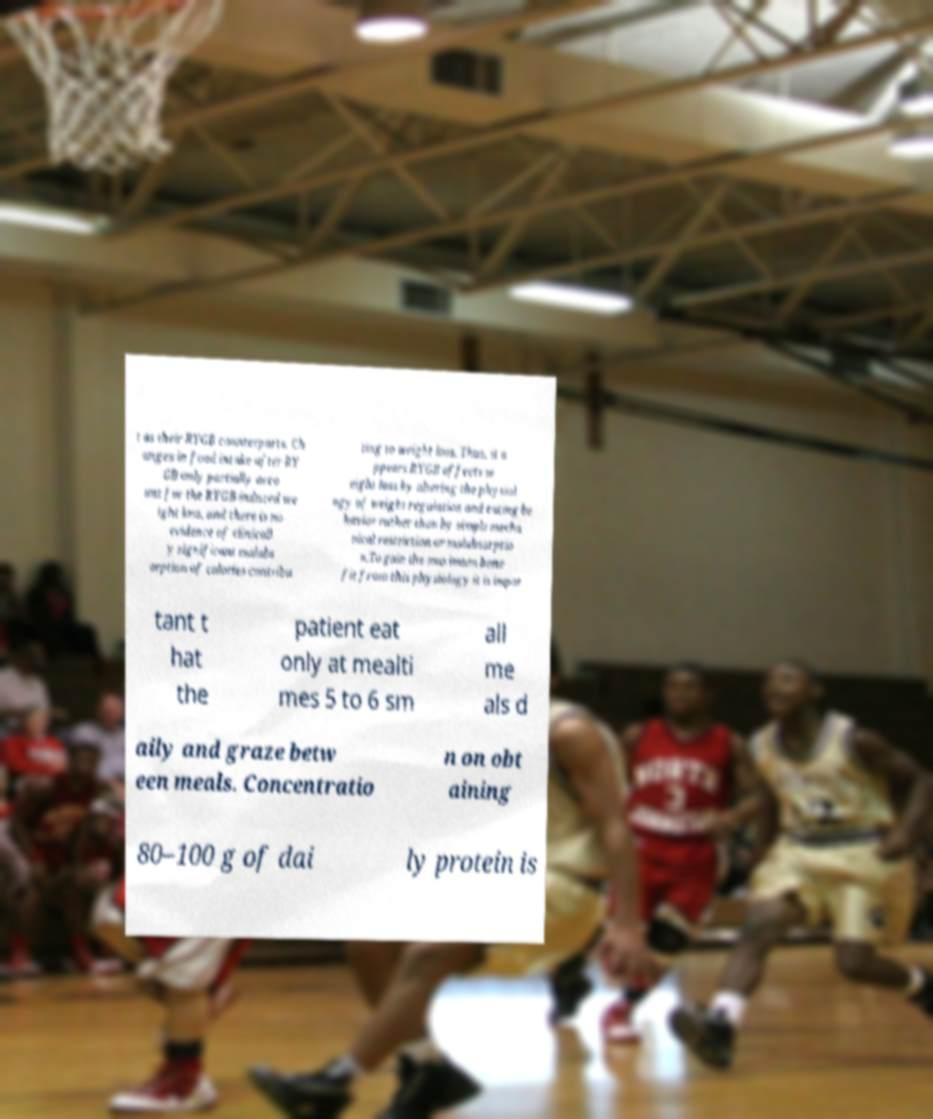I need the written content from this picture converted into text. Can you do that? t as their RYGB counterparts. Ch anges in food intake after RY GB only partially acco unt for the RYGB-induced we ight loss, and there is no evidence of clinicall y significant malabs orption of calories contribu ting to weight loss. Thus, it a ppears RYGB affects w eight loss by altering the physiol ogy of weight regulation and eating be havior rather than by simple mecha nical restriction or malabsorptio n.To gain the maximum bene fit from this physiology it is impor tant t hat the patient eat only at mealti mes 5 to 6 sm all me als d aily and graze betw een meals. Concentratio n on obt aining 80–100 g of dai ly protein is 